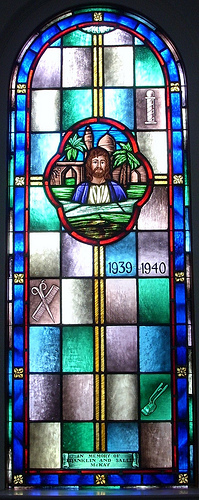<image>
Is there a man on the window? Yes. Looking at the image, I can see the man is positioned on top of the window, with the window providing support. 